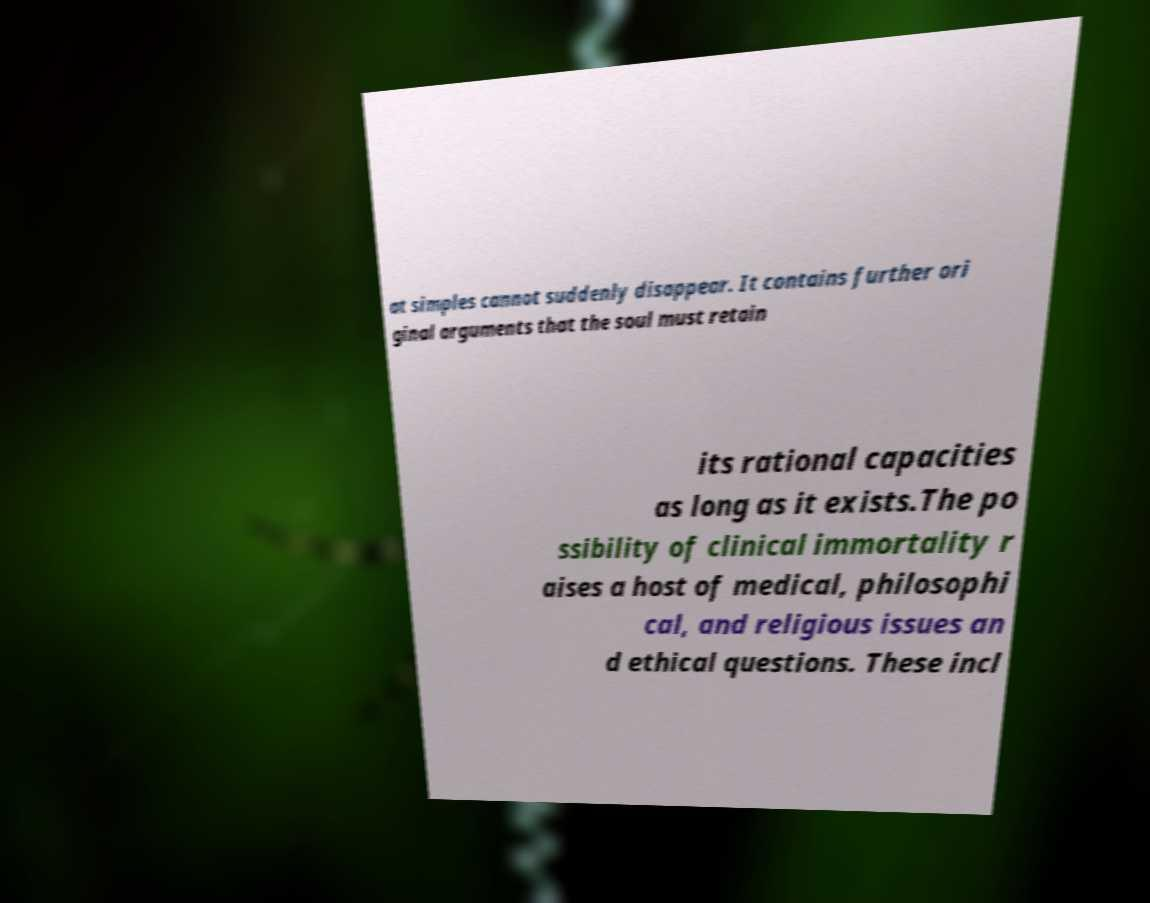Please read and relay the text visible in this image. What does it say? at simples cannot suddenly disappear. It contains further ori ginal arguments that the soul must retain its rational capacities as long as it exists.The po ssibility of clinical immortality r aises a host of medical, philosophi cal, and religious issues an d ethical questions. These incl 